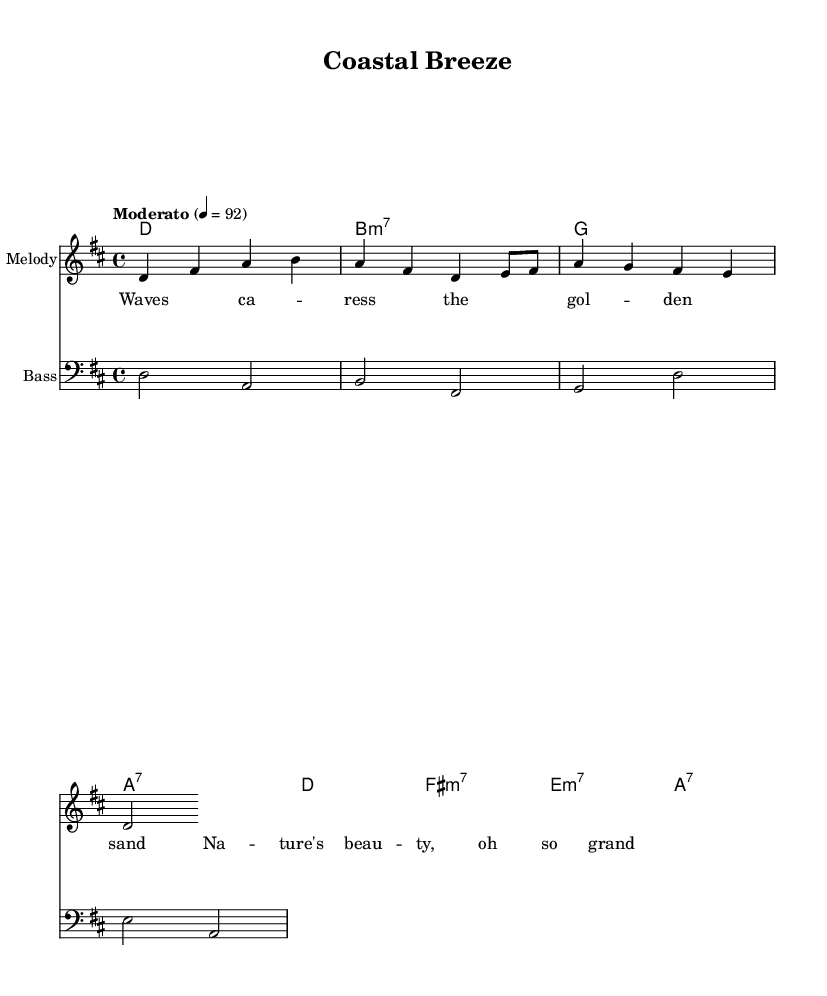What is the key signature of this music? The key signature is indicated at the beginning of the score, showing two sharps, which corresponds to D major.
Answer: D major What is the time signature of this piece? The time signature is found at the beginning of the score, shown as a fraction with a 4 on top of a 4, indicating a common time signature of four beats per measure.
Answer: 4/4 What is the tempo marking for this composition? The tempo marking is present above the staff and reads "Moderato" followed by a metronome marking of 4 = 92, which instructs the performer to play at a moderate speed of 92 beats per minute.
Answer: Moderato, 92 What is the opening note of the melody? The first note of the melody is indicated at the beginning of the melody staff, where the note D on the second line is the starting point.
Answer: D How many measures are there in the melody? By counting each grouping of notes and rests between the bar lines, we find there are a total of 8 measures in the melody section of the score.
Answer: 8 What type of musical piece is represented here? This piece displays characteristics typical of bossa nova, which combines elements of samba and jazz, as inferred from its rhythm and harmonic structure.
Answer: Bossa nova 